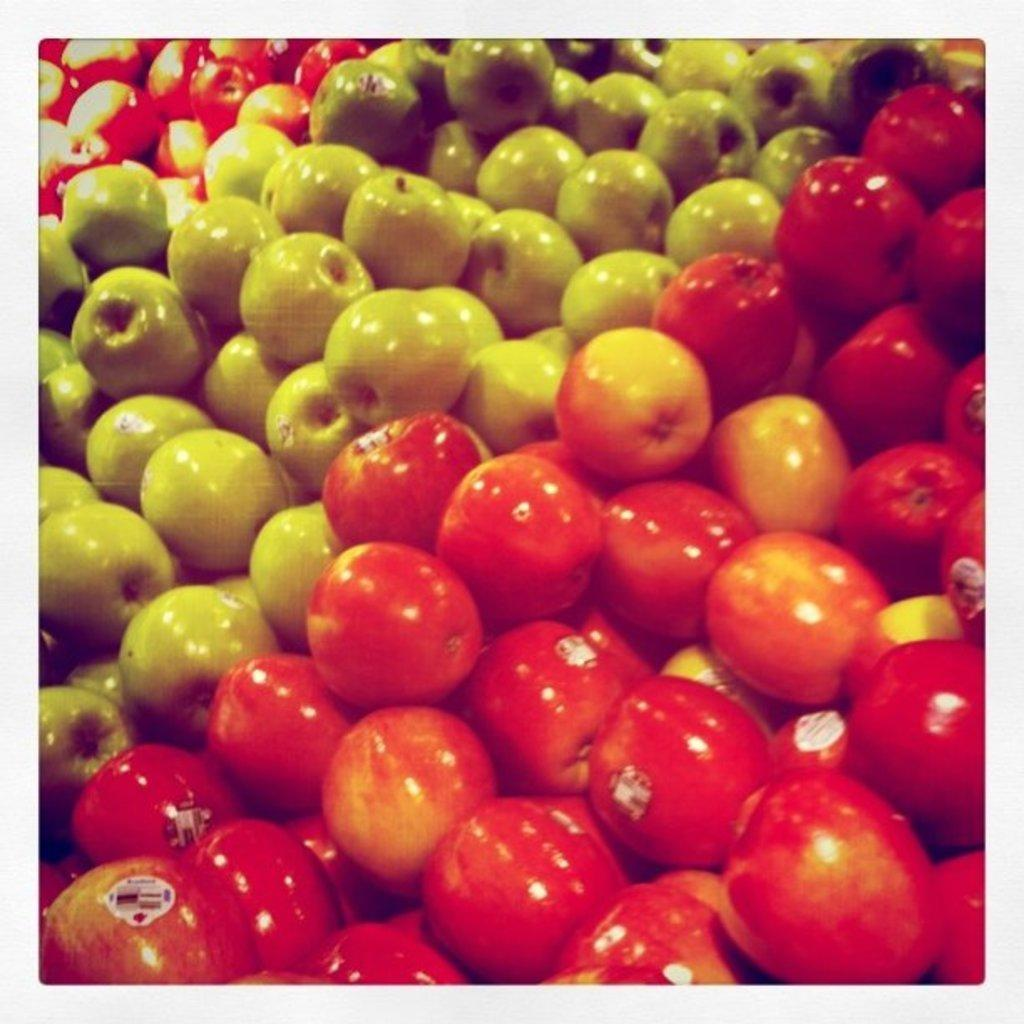What type of fruit is visible in the image? There are bunches of red apples and green apples in the image. Can you describe the color of the red apples? The red apples in the image are red. What is the color of the green apples? The green apples in the image are green. Where is the nearest market to the location of the apples in the image? The provided facts do not give any information about the location of the apples or the nearest market, so it cannot be determined from the image. What type of railway is visible in the image? There is no railway present in the image; it features bunches of red and green apples. 